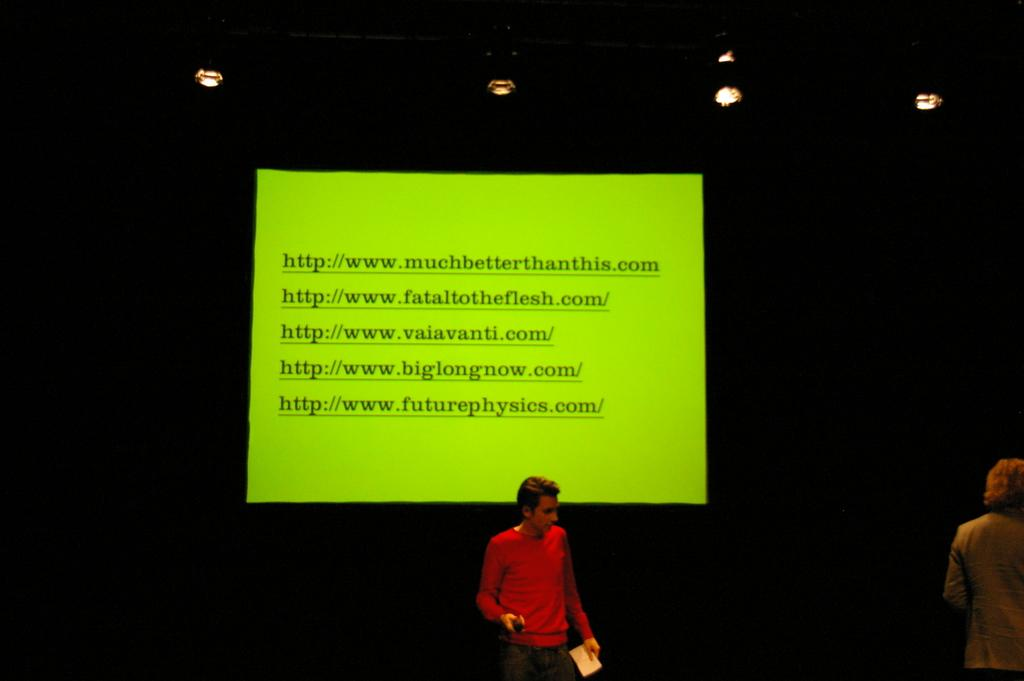Who is present in the image? There is a man in the image. What is the man doing in the image? The man is standing in the image. What is the man wearing in the image? The man is wearing a red shirt in the image. What is the man holding in the image? The man is holding a paper in his hands in the image. What can be seen on the paper the man is holding? There is writing on the paper in the image. What is the source of illumination in the image? There is light in the image. How does the man jump in the image? The man is not jumping in the image; he is standing. What is the expansion of the paper the man is holding? There is no mention of an expansion of the paper in the image; it is simply a paper with writing on it. 